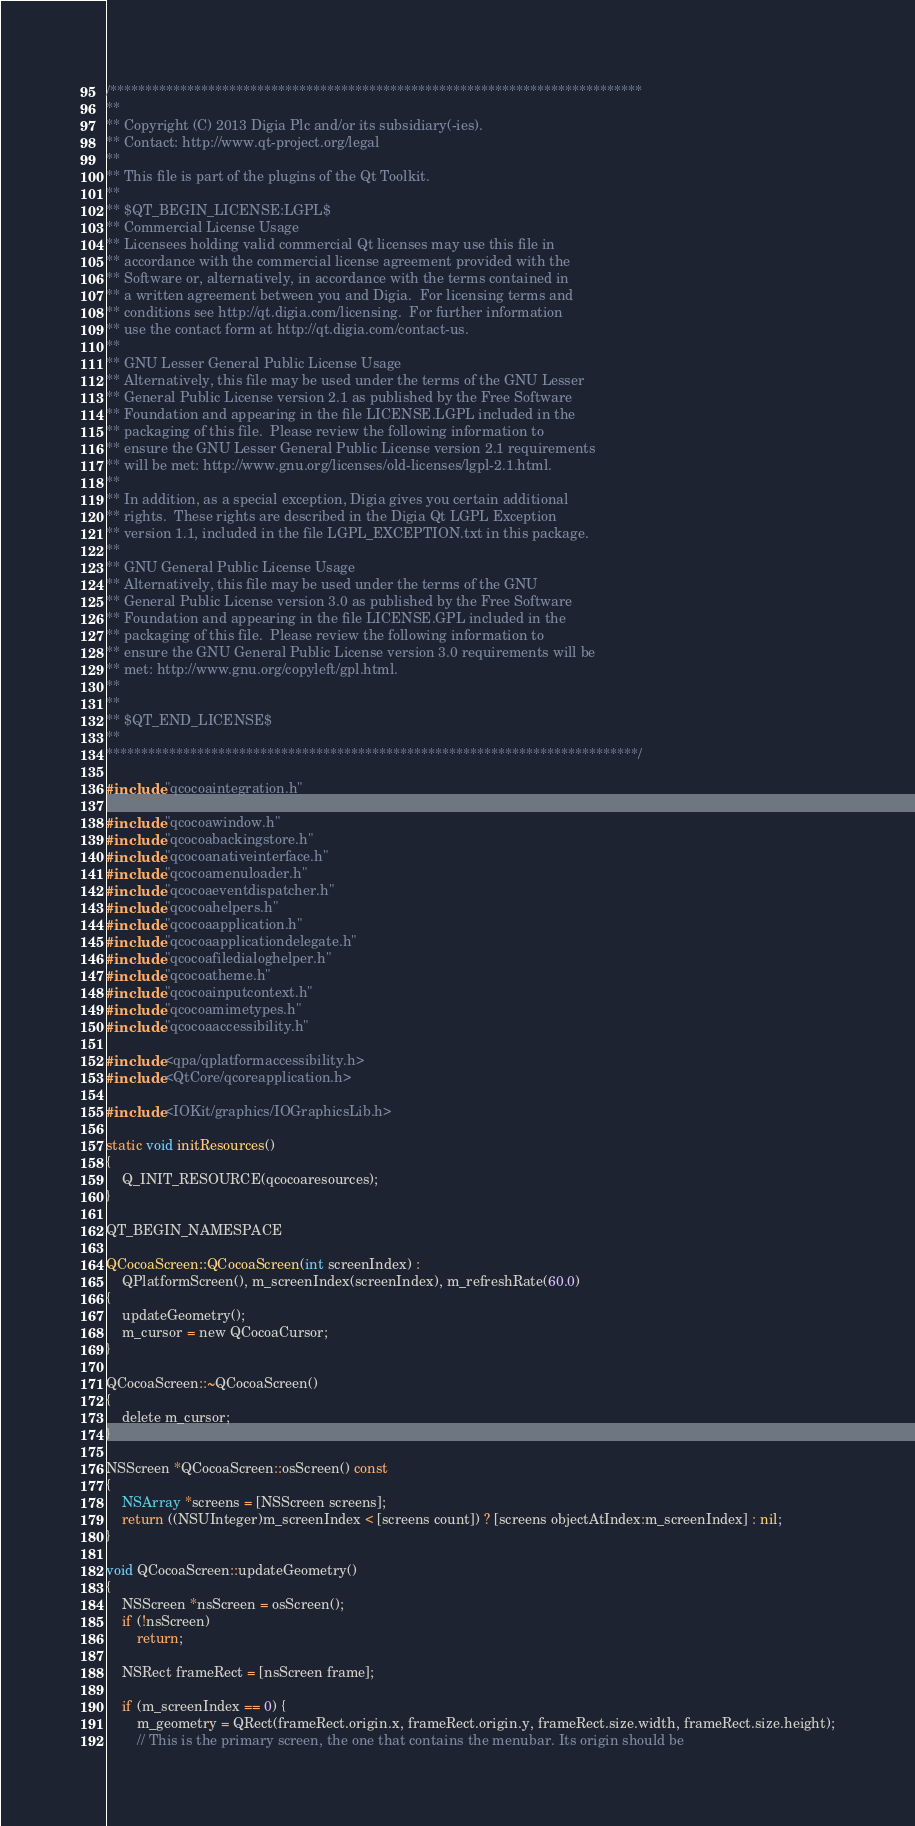Convert code to text. <code><loc_0><loc_0><loc_500><loc_500><_ObjectiveC_>/****************************************************************************
**
** Copyright (C) 2013 Digia Plc and/or its subsidiary(-ies).
** Contact: http://www.qt-project.org/legal
**
** This file is part of the plugins of the Qt Toolkit.
**
** $QT_BEGIN_LICENSE:LGPL$
** Commercial License Usage
** Licensees holding valid commercial Qt licenses may use this file in
** accordance with the commercial license agreement provided with the
** Software or, alternatively, in accordance with the terms contained in
** a written agreement between you and Digia.  For licensing terms and
** conditions see http://qt.digia.com/licensing.  For further information
** use the contact form at http://qt.digia.com/contact-us.
**
** GNU Lesser General Public License Usage
** Alternatively, this file may be used under the terms of the GNU Lesser
** General Public License version 2.1 as published by the Free Software
** Foundation and appearing in the file LICENSE.LGPL included in the
** packaging of this file.  Please review the following information to
** ensure the GNU Lesser General Public License version 2.1 requirements
** will be met: http://www.gnu.org/licenses/old-licenses/lgpl-2.1.html.
**
** In addition, as a special exception, Digia gives you certain additional
** rights.  These rights are described in the Digia Qt LGPL Exception
** version 1.1, included in the file LGPL_EXCEPTION.txt in this package.
**
** GNU General Public License Usage
** Alternatively, this file may be used under the terms of the GNU
** General Public License version 3.0 as published by the Free Software
** Foundation and appearing in the file LICENSE.GPL included in the
** packaging of this file.  Please review the following information to
** ensure the GNU General Public License version 3.0 requirements will be
** met: http://www.gnu.org/copyleft/gpl.html.
**
**
** $QT_END_LICENSE$
**
****************************************************************************/

#include "qcocoaintegration.h"

#include "qcocoawindow.h"
#include "qcocoabackingstore.h"
#include "qcocoanativeinterface.h"
#include "qcocoamenuloader.h"
#include "qcocoaeventdispatcher.h"
#include "qcocoahelpers.h"
#include "qcocoaapplication.h"
#include "qcocoaapplicationdelegate.h"
#include "qcocoafiledialoghelper.h"
#include "qcocoatheme.h"
#include "qcocoainputcontext.h"
#include "qcocoamimetypes.h"
#include "qcocoaaccessibility.h"

#include <qpa/qplatformaccessibility.h>
#include <QtCore/qcoreapplication.h>

#include <IOKit/graphics/IOGraphicsLib.h>

static void initResources()
{
    Q_INIT_RESOURCE(qcocoaresources);
}

QT_BEGIN_NAMESPACE

QCocoaScreen::QCocoaScreen(int screenIndex) :
    QPlatformScreen(), m_screenIndex(screenIndex), m_refreshRate(60.0)
{
    updateGeometry();
    m_cursor = new QCocoaCursor;
}

QCocoaScreen::~QCocoaScreen()
{
    delete m_cursor;
}

NSScreen *QCocoaScreen::osScreen() const
{
    NSArray *screens = [NSScreen screens];
    return ((NSUInteger)m_screenIndex < [screens count]) ? [screens objectAtIndex:m_screenIndex] : nil;
}

void QCocoaScreen::updateGeometry()
{
    NSScreen *nsScreen = osScreen();
    if (!nsScreen)
        return;

    NSRect frameRect = [nsScreen frame];

    if (m_screenIndex == 0) {
        m_geometry = QRect(frameRect.origin.x, frameRect.origin.y, frameRect.size.width, frameRect.size.height);
        // This is the primary screen, the one that contains the menubar. Its origin should be</code> 